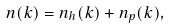Convert formula to latex. <formula><loc_0><loc_0><loc_500><loc_500>n ( k ) = n _ { h } ( k ) + n _ { p } ( k ) ,</formula> 